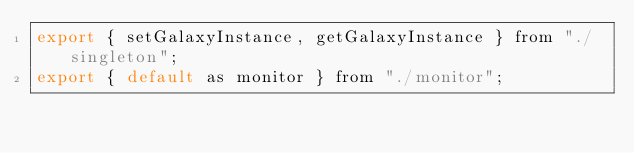Convert code to text. <code><loc_0><loc_0><loc_500><loc_500><_JavaScript_>export { setGalaxyInstance, getGalaxyInstance } from "./singleton";
export { default as monitor } from "./monitor";
</code> 